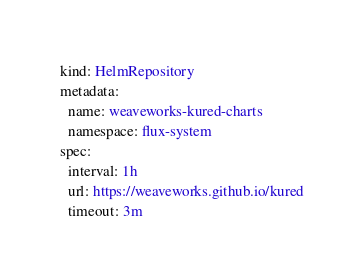Convert code to text. <code><loc_0><loc_0><loc_500><loc_500><_YAML_>kind: HelmRepository
metadata:
  name: weaveworks-kured-charts
  namespace: flux-system
spec:
  interval: 1h
  url: https://weaveworks.github.io/kured
  timeout: 3m
</code> 